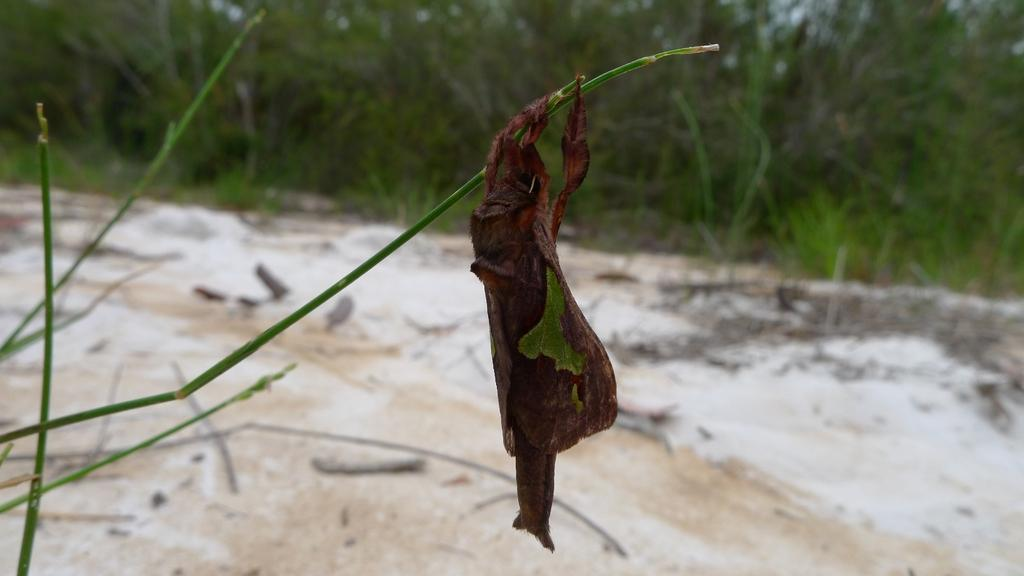What is the main object in the image? There is a stem in the image. What is attached to the stem? There is a brown color thing on the stem, which resembles a crustacean animal. What type of surface is visible in the image? There is ground visible in the image. What can be seen in the distance in the image? There are trees in the background of the image. What type of picture is hanging on the wall in the image? There is no mention of a picture hanging on the wall in the image; the facts provided only discuss a stem, a brown crustacean-like thing, ground, and trees in the background. 